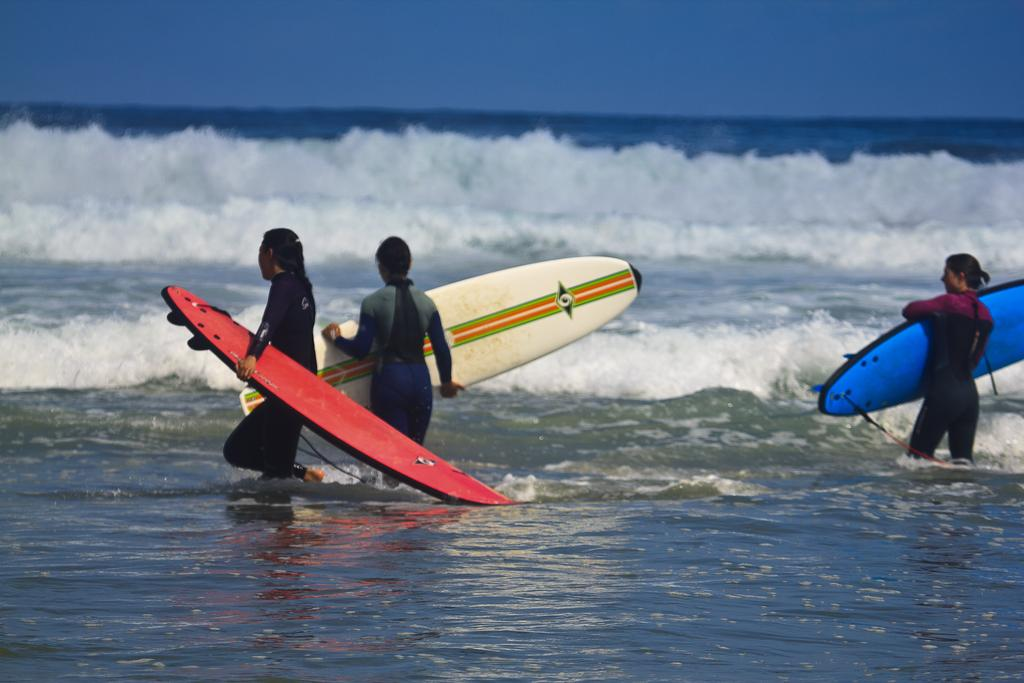How many persons are in the image? There are persons in the image. What are the persons holding in the image? The persons are holding surfboards. Where are the persons located in the image? The persons are in the water. What can be seen in the background of the image? There is sea and sky visible in the background of the image. What type of cushion can be seen supporting the beef on the steel table in the image? There is no cushion, beef, or steel table present in the image. 